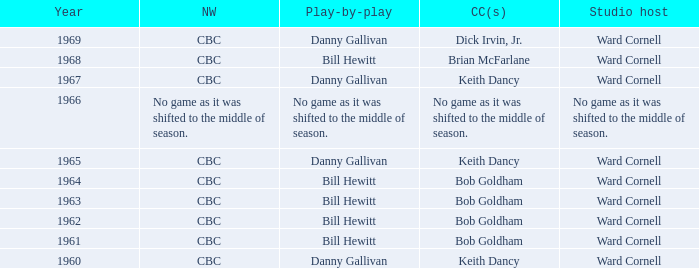Could you help me parse every detail presented in this table? {'header': ['Year', 'NW', 'Play-by-play', 'CC(s)', 'Studio host'], 'rows': [['1969', 'CBC', 'Danny Gallivan', 'Dick Irvin, Jr.', 'Ward Cornell'], ['1968', 'CBC', 'Bill Hewitt', 'Brian McFarlane', 'Ward Cornell'], ['1967', 'CBC', 'Danny Gallivan', 'Keith Dancy', 'Ward Cornell'], ['1966', 'No game as it was shifted to the middle of season.', 'No game as it was shifted to the middle of season.', 'No game as it was shifted to the middle of season.', 'No game as it was shifted to the middle of season.'], ['1965', 'CBC', 'Danny Gallivan', 'Keith Dancy', 'Ward Cornell'], ['1964', 'CBC', 'Bill Hewitt', 'Bob Goldham', 'Ward Cornell'], ['1963', 'CBC', 'Bill Hewitt', 'Bob Goldham', 'Ward Cornell'], ['1962', 'CBC', 'Bill Hewitt', 'Bob Goldham', 'Ward Cornell'], ['1961', 'CBC', 'Bill Hewitt', 'Bob Goldham', 'Ward Cornell'], ['1960', 'CBC', 'Danny Gallivan', 'Keith Dancy', 'Ward Cornell']]} Were the color commentators who worked with Bill Hewitt doing the play-by-play? Brian McFarlane, Bob Goldham, Bob Goldham, Bob Goldham, Bob Goldham. 